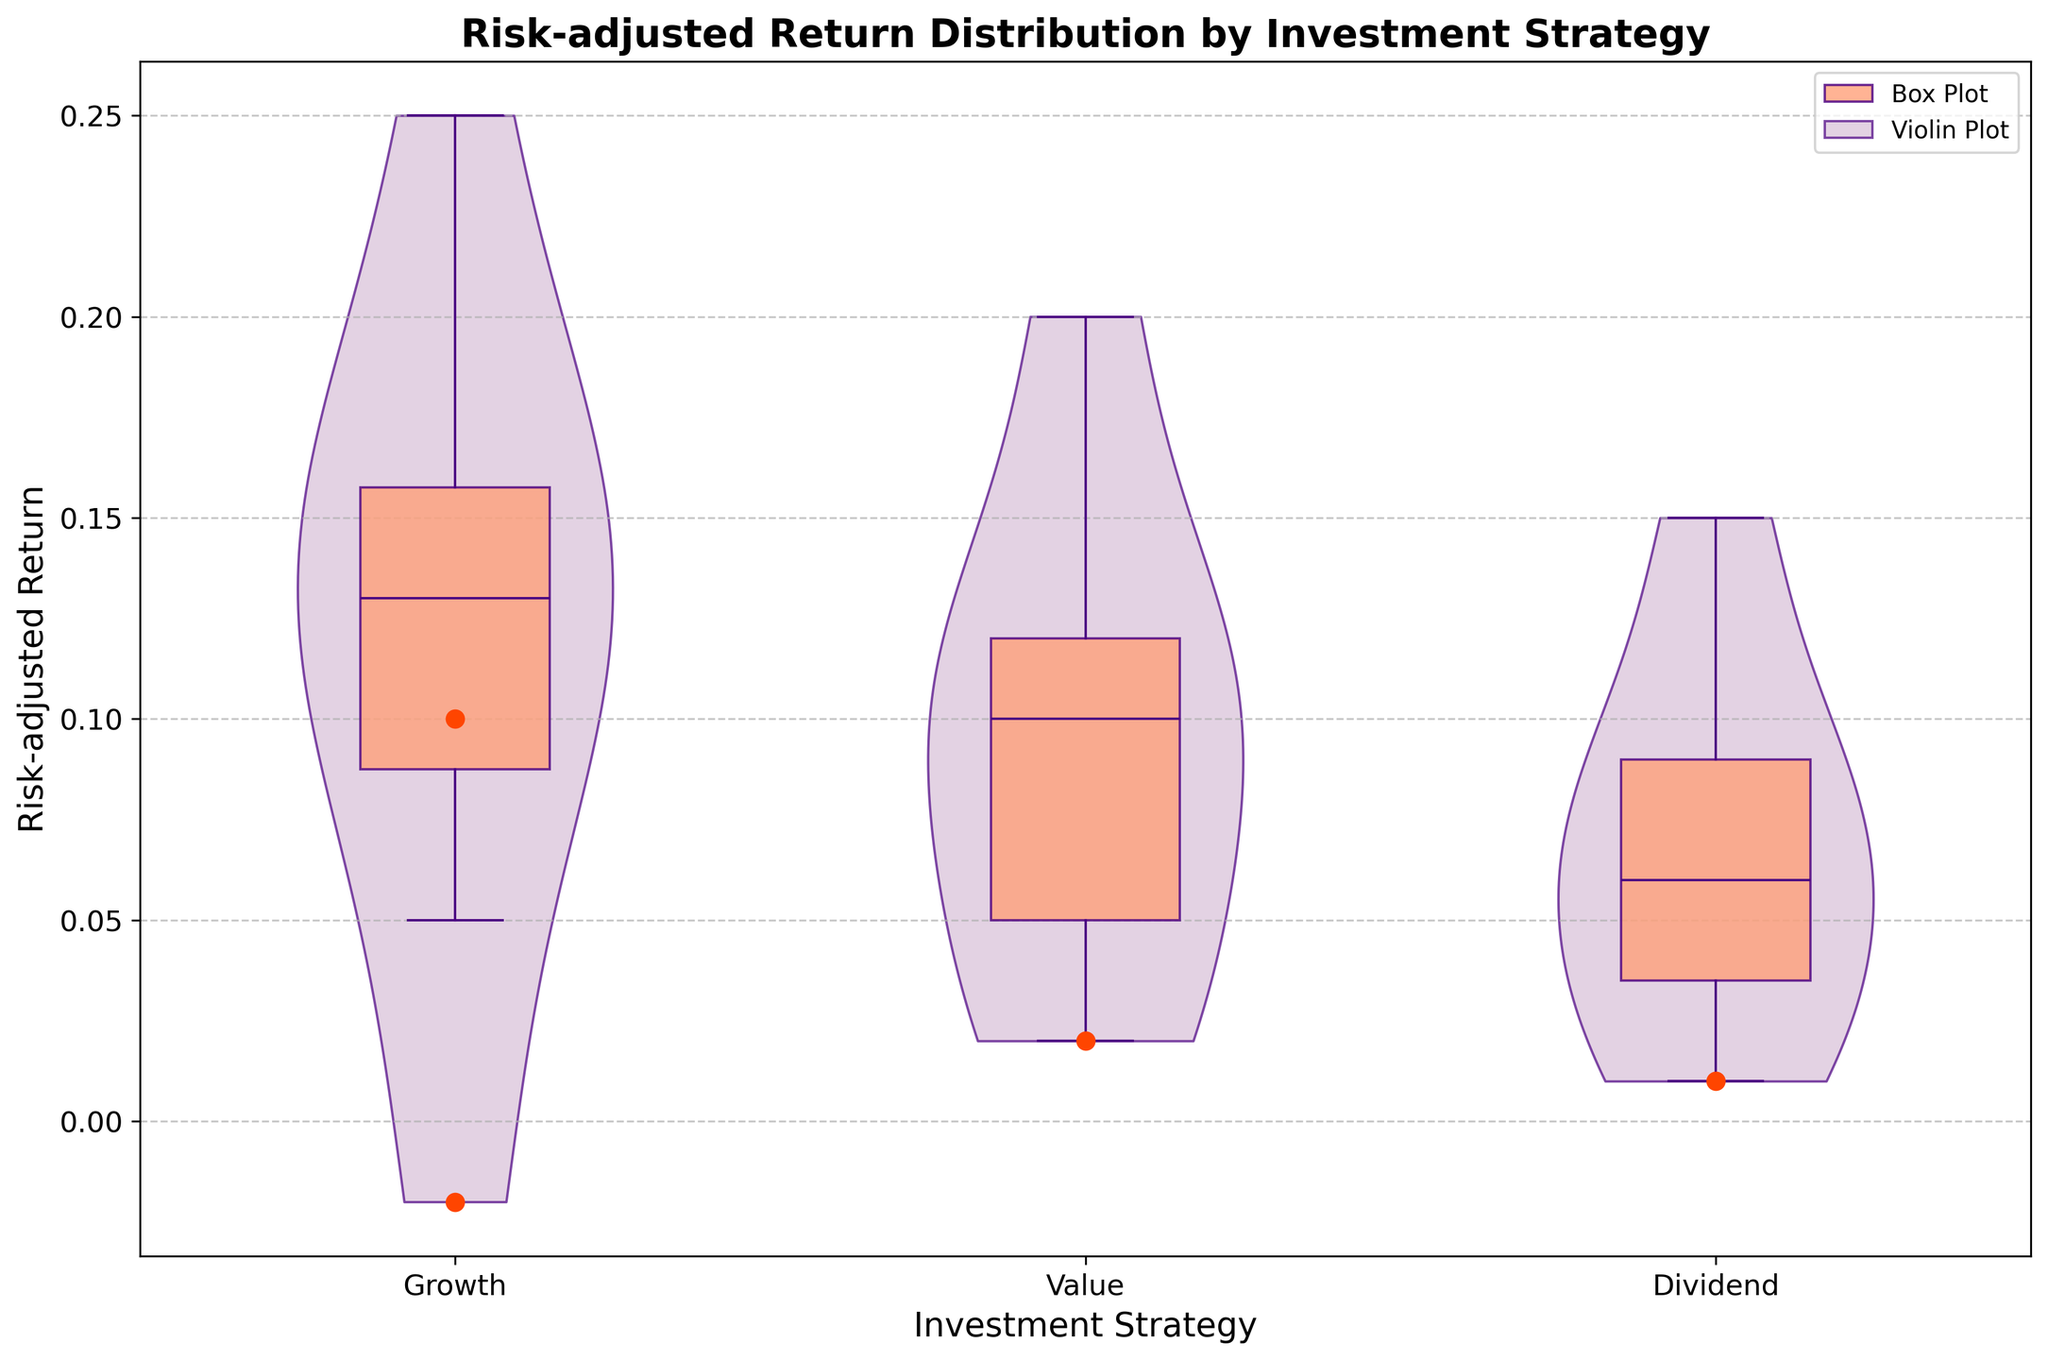What is the median return for each investment strategy? By looking at the center line within the boxes of the box plots for each investment strategy, we can see the median values. The median return values are 0.15 for Growth, 0.10 for Value, and 0.08 for Dividend.
Answer: Growth: 0.15; Value: 0.10; Dividend: 0.08 What is the range of risk-adjusted returns for the Growth strategy? The range is determined by subtracting the lower whisker value from the upper whisker value. For the Growth strategy, the upper whisker is 0.25 and the lower whisker is 0.05. Thus, the range is 0.25 - 0.05 = 0.20.
Answer: 0.20 Which strategy has the highest upper quartile return and what is the value? The upper quartile return is indicated by the top edge of the box in the box plots. The Growth strategy has the highest upper quartile return at 0.18.
Answer: Growth, 0.18 Are there any outliers in the Dividend strategy? By looking at the plot, we can spot outliers indicated as individual points beyond the whiskers. The Dividend strategy has outliers, specifically values at 0.01.
Answer: Yes How do the interquartile ranges (IQRs) of the different strategies compare? The IQR is the height of the box in the box plot. For Growth, it's 0.14 (0.18 - 0.12); for Value, it's 0.06 (0.13 - 0.07); and for Dividend, it's 0.05 (0.10 - 0.05). Growth has the largest IQR, followed by Value, and then Dividend.
Answer: Growth > Value > Dividend Which strategy shows the most variability in returns based on the violin plot shapes? The width of the violin plot indicates the density of values. The Growth strategy displays the most variability with a wider distribution, whereas the Dividend strategy has the least variability.
Answer: Growth Compare the lower whisker values of each investment strategy. The lower whisker values can be seen at the bottom end of the whiskers in the box plots. The lower whisker values are 0.05 for Growth, 0.03 for Value, and 0.02 for Dividend.
Answer: Growth: 0.05; Value: 0.03; Dividend: 0.02 Which investment strategy has a less symmetrical distribution around the median based on the violin plots? The less symmetrical distribution is seen where the violin plot shows more spread on one side of the median compared to the other. The Dividend strategy shows more asymmetry with a wider spread below the median.
Answer: Dividend 